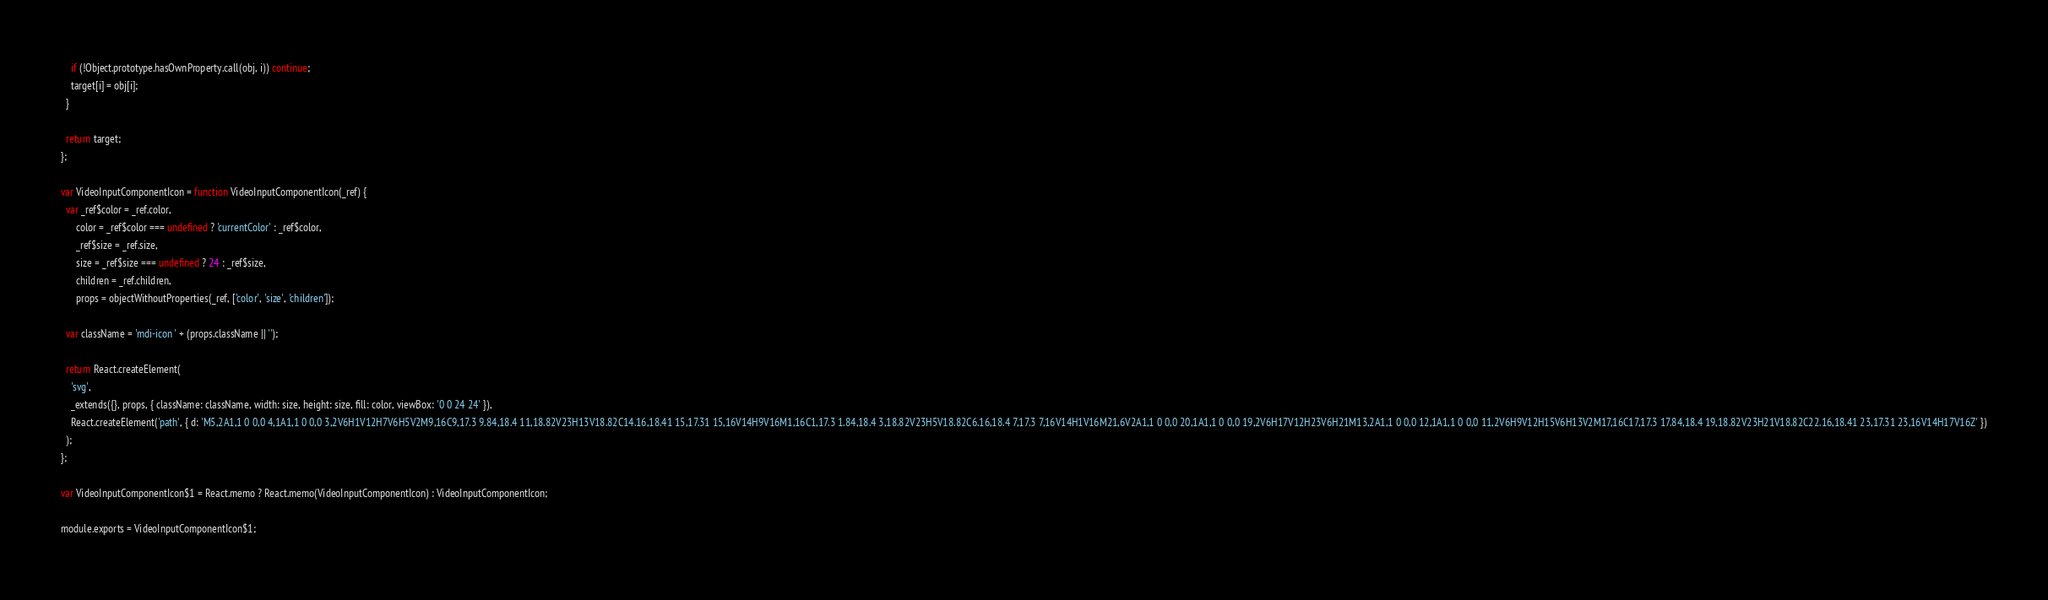Convert code to text. <code><loc_0><loc_0><loc_500><loc_500><_JavaScript_>    if (!Object.prototype.hasOwnProperty.call(obj, i)) continue;
    target[i] = obj[i];
  }

  return target;
};

var VideoInputComponentIcon = function VideoInputComponentIcon(_ref) {
  var _ref$color = _ref.color,
      color = _ref$color === undefined ? 'currentColor' : _ref$color,
      _ref$size = _ref.size,
      size = _ref$size === undefined ? 24 : _ref$size,
      children = _ref.children,
      props = objectWithoutProperties(_ref, ['color', 'size', 'children']);

  var className = 'mdi-icon ' + (props.className || '');

  return React.createElement(
    'svg',
    _extends({}, props, { className: className, width: size, height: size, fill: color, viewBox: '0 0 24 24' }),
    React.createElement('path', { d: 'M5,2A1,1 0 0,0 4,1A1,1 0 0,0 3,2V6H1V12H7V6H5V2M9,16C9,17.3 9.84,18.4 11,18.82V23H13V18.82C14.16,18.41 15,17.31 15,16V14H9V16M1,16C1,17.3 1.84,18.4 3,18.82V23H5V18.82C6.16,18.4 7,17.3 7,16V14H1V16M21,6V2A1,1 0 0,0 20,1A1,1 0 0,0 19,2V6H17V12H23V6H21M13,2A1,1 0 0,0 12,1A1,1 0 0,0 11,2V6H9V12H15V6H13V2M17,16C17,17.3 17.84,18.4 19,18.82V23H21V18.82C22.16,18.41 23,17.31 23,16V14H17V16Z' })
  );
};

var VideoInputComponentIcon$1 = React.memo ? React.memo(VideoInputComponentIcon) : VideoInputComponentIcon;

module.exports = VideoInputComponentIcon$1;
</code> 